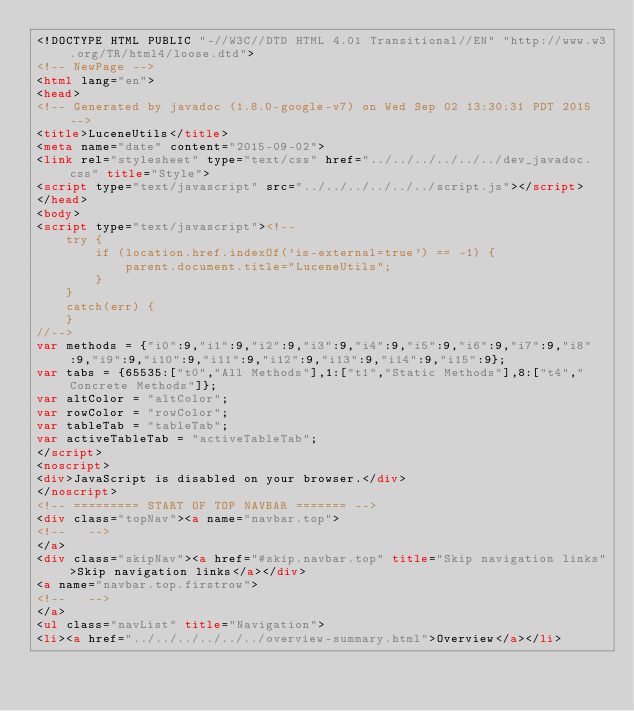Convert code to text. <code><loc_0><loc_0><loc_500><loc_500><_HTML_><!DOCTYPE HTML PUBLIC "-//W3C//DTD HTML 4.01 Transitional//EN" "http://www.w3.org/TR/html4/loose.dtd">
<!-- NewPage -->
<html lang="en">
<head>
<!-- Generated by javadoc (1.8.0-google-v7) on Wed Sep 02 13:30:31 PDT 2015 -->
<title>LuceneUtils</title>
<meta name="date" content="2015-09-02">
<link rel="stylesheet" type="text/css" href="../../../../../../dev_javadoc.css" title="Style">
<script type="text/javascript" src="../../../../../../script.js"></script>
</head>
<body>
<script type="text/javascript"><!--
    try {
        if (location.href.indexOf('is-external=true') == -1) {
            parent.document.title="LuceneUtils";
        }
    }
    catch(err) {
    }
//-->
var methods = {"i0":9,"i1":9,"i2":9,"i3":9,"i4":9,"i5":9,"i6":9,"i7":9,"i8":9,"i9":9,"i10":9,"i11":9,"i12":9,"i13":9,"i14":9,"i15":9};
var tabs = {65535:["t0","All Methods"],1:["t1","Static Methods"],8:["t4","Concrete Methods"]};
var altColor = "altColor";
var rowColor = "rowColor";
var tableTab = "tableTab";
var activeTableTab = "activeTableTab";
</script>
<noscript>
<div>JavaScript is disabled on your browser.</div>
</noscript>
<!-- ========= START OF TOP NAVBAR ======= -->
<div class="topNav"><a name="navbar.top">
<!--   -->
</a>
<div class="skipNav"><a href="#skip.navbar.top" title="Skip navigation links">Skip navigation links</a></div>
<a name="navbar.top.firstrow">
<!--   -->
</a>
<ul class="navList" title="Navigation">
<li><a href="../../../../../../overview-summary.html">Overview</a></li></code> 